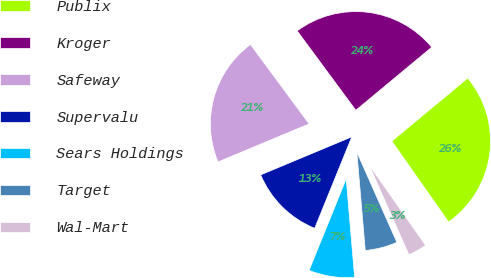Convert chart. <chart><loc_0><loc_0><loc_500><loc_500><pie_chart><fcel>Publix<fcel>Kroger<fcel>Safeway<fcel>Supervalu<fcel>Sears Holdings<fcel>Target<fcel>Wal-Mart<nl><fcel>26.29%<fcel>24.09%<fcel>21.17%<fcel>12.57%<fcel>7.49%<fcel>5.29%<fcel>3.09%<nl></chart> 